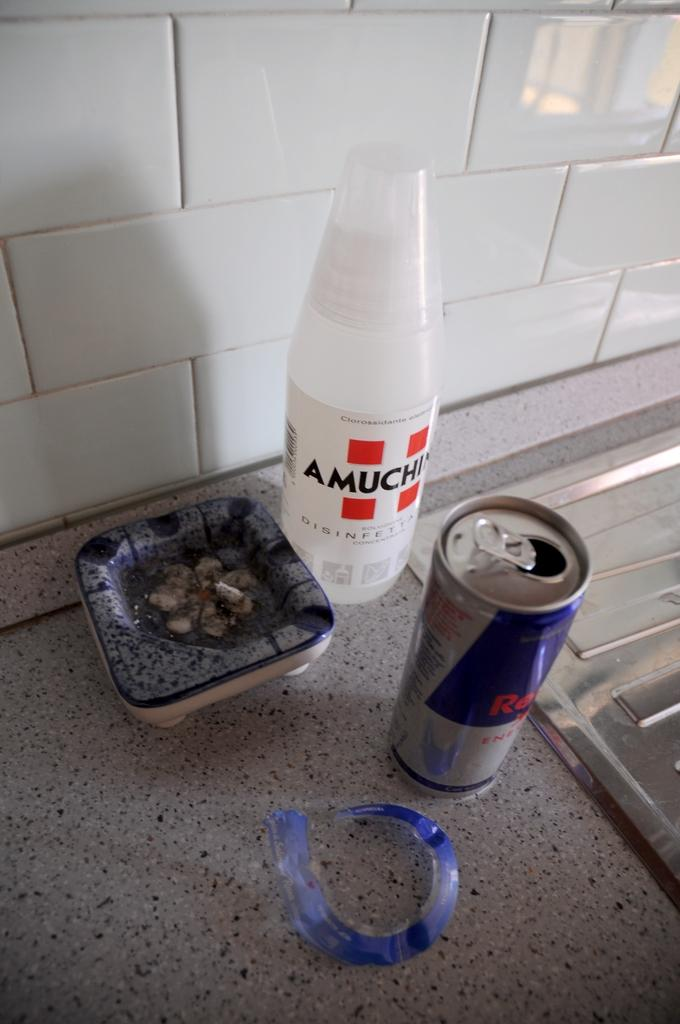<image>
Describe the image concisely. A white bottle has a label with the letters AMUCHI visible. 